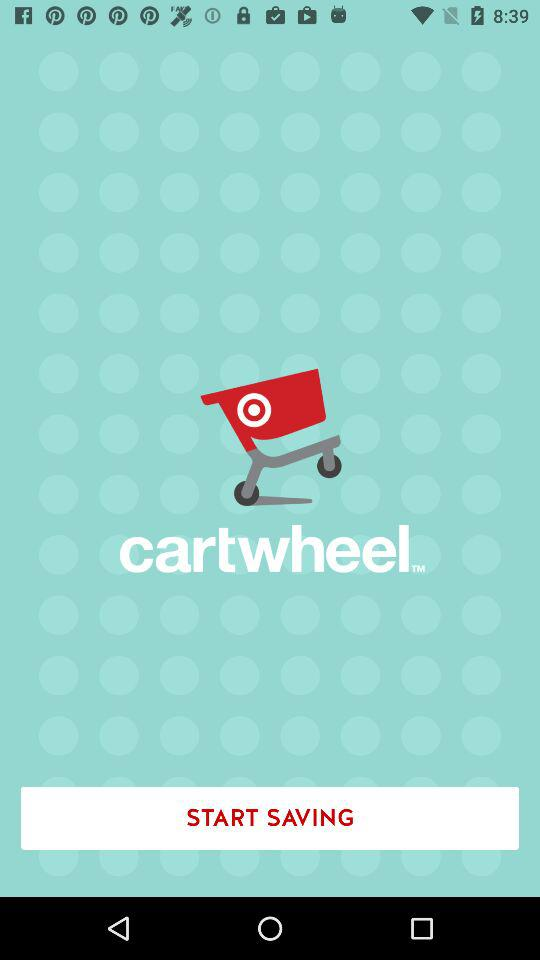What is the name of the application? The application name is "cartwheel". 